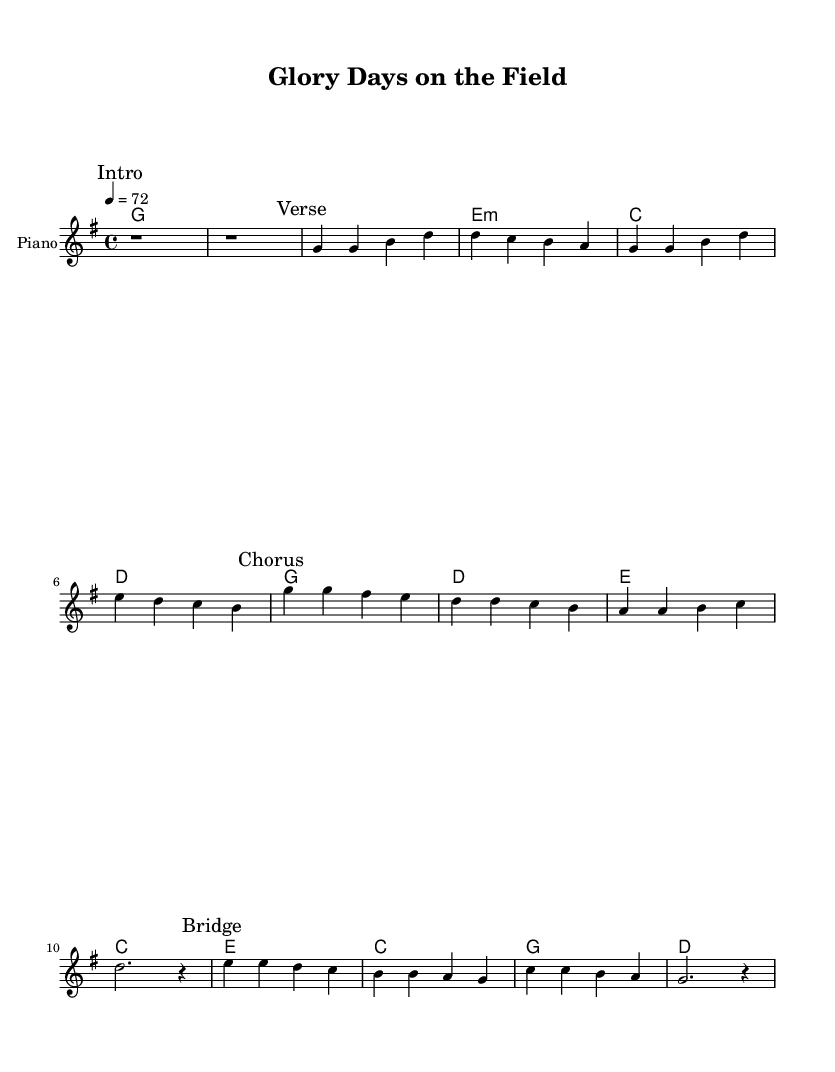What is the key signature of this music? The key signature is G major, as indicated by the single sharp (F#) at the beginning of the staff.
Answer: G major What is the time signature of this music? The time signature is 4/4, as shown near the beginning of the staff, indicating four beats per measure.
Answer: 4/4 What is the tempo marking of the piece? The tempo marking is 72 beats per minute (BPM), which is indicated by the "tempo 4 = 72" instruction at the top of the sheet music.
Answer: 72 How many measures are in the verse section? The verse section has four measures, which can be counted from the melody line where the "Verse" mark is located.
Answer: 4 What is the structure of the song? The structure includes an introduction, verse, chorus, and bridge, as indicated by the marked sections throughout the sheet music.
Answer: Intro, Verse, Chorus, Bridge What is the primary function of the chorus in this pop ballad? The chorus typically serves as the memorable, repeated section that conveys the main message or theme of the song, providing emotional impact.
Answer: Memorable section What is the predominant harmony used in the chorus? The predominant harmony used in the chorus is based on G, D, C, and A chords, as can be seen from the chord names written above the melody in that section.
Answer: G, D, C, A 